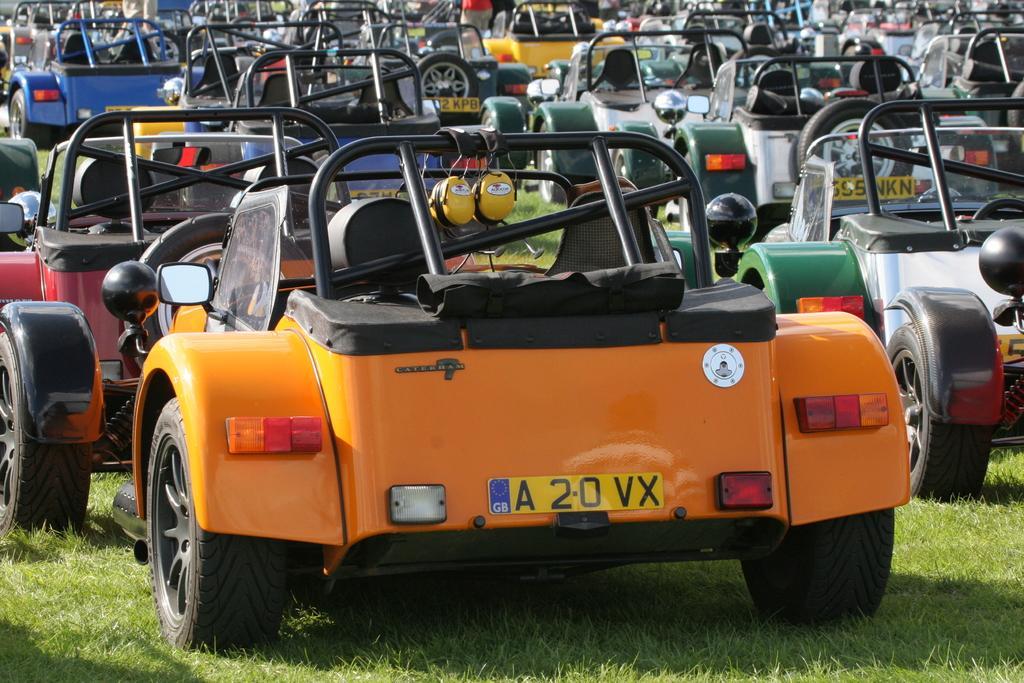Can you describe this image briefly? In this picture we can see so many vehicles are parked on the grass. 